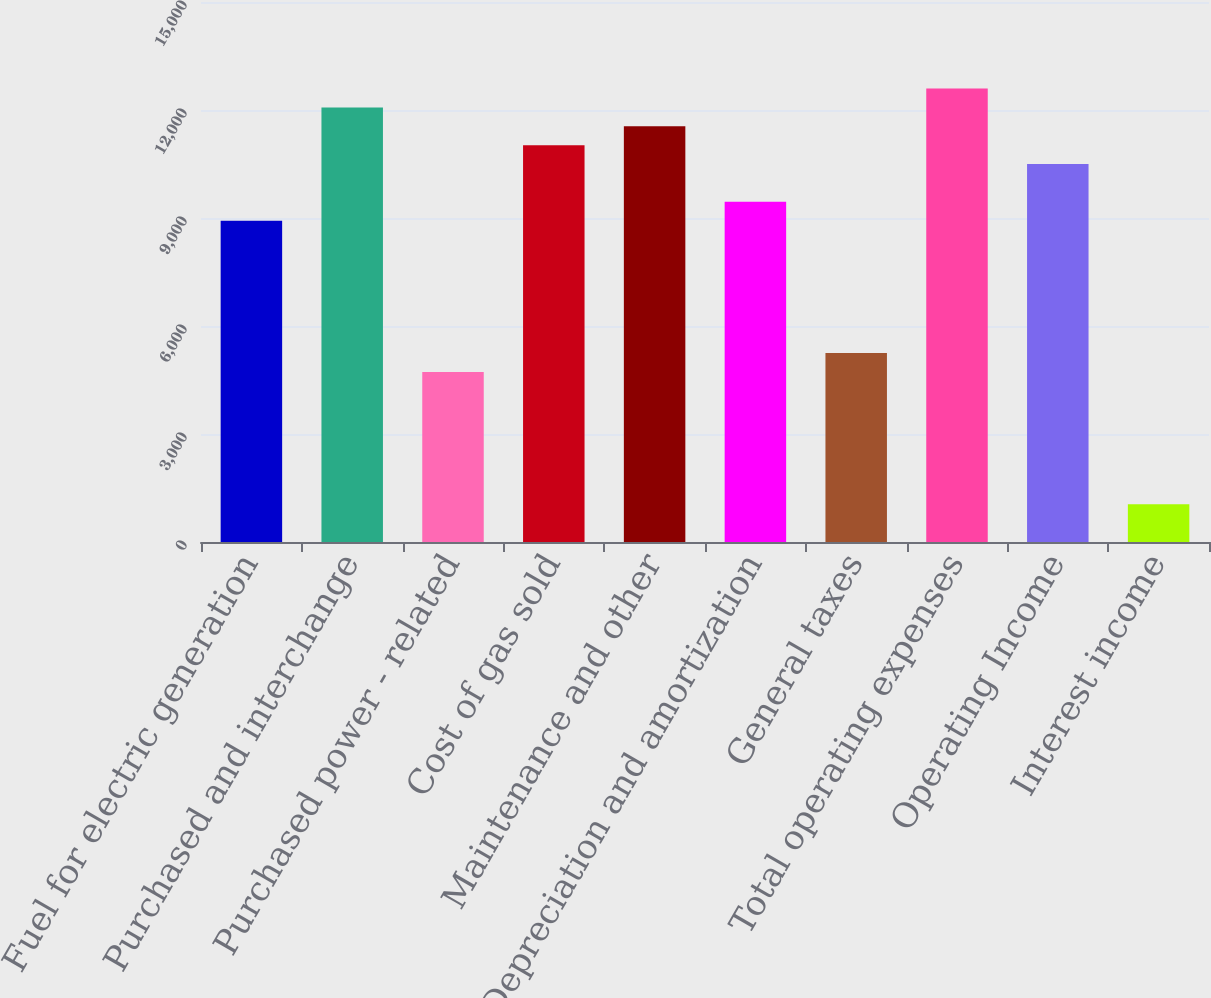Convert chart. <chart><loc_0><loc_0><loc_500><loc_500><bar_chart><fcel>Fuel for electric generation<fcel>Purchased and interchange<fcel>Purchased power - related<fcel>Cost of gas sold<fcel>Maintenance and other<fcel>Depreciation and amortization<fcel>General taxes<fcel>Total operating expenses<fcel>Operating Income<fcel>Interest income<nl><fcel>8923.6<fcel>12072.4<fcel>4725.2<fcel>11022.8<fcel>11547.6<fcel>9448.4<fcel>5250<fcel>12597.2<fcel>10498<fcel>1051.6<nl></chart> 